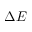Convert formula to latex. <formula><loc_0><loc_0><loc_500><loc_500>\Delta E</formula> 